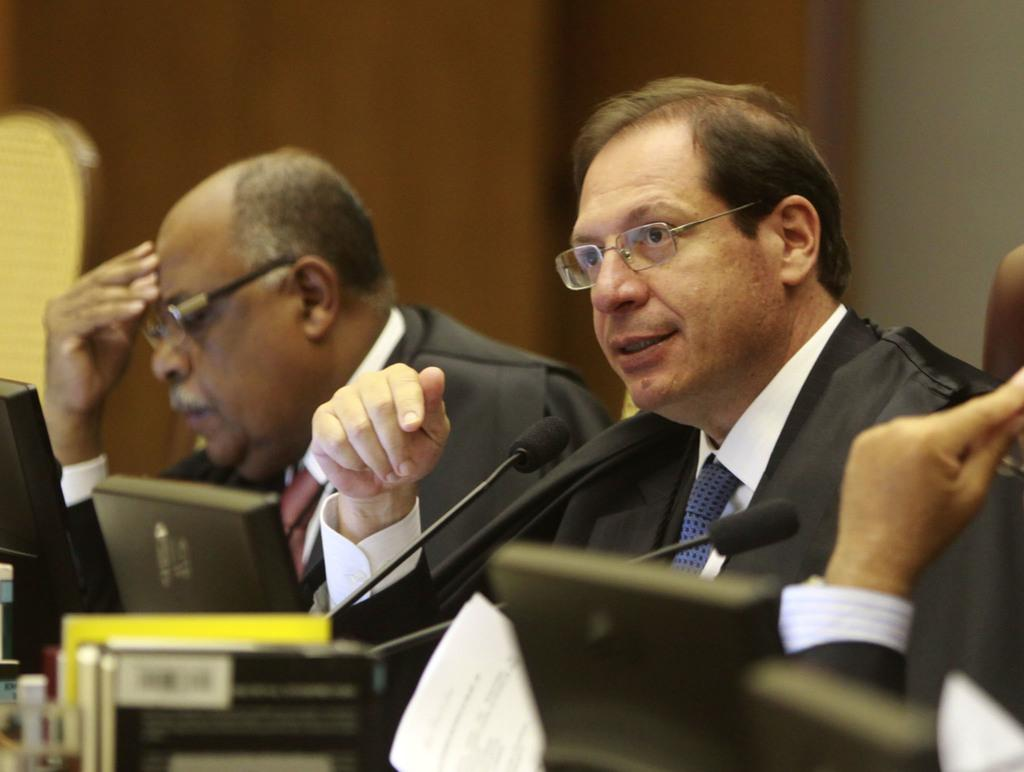Who or what can be seen in the image? There are people and mice in the image. What are the people using in the image? The people are using laptops in the image. What else can be found on the laptops? There are papers on the laptops in the image. What other objects are present in the image? There are other objects in the image, but their specific details are not mentioned in the facts. How is the background of the image depicted? The background of the image is blurred. How many girls are present in the image? The facts provided do not mention any girls in the image. What is the uncle doing in the image? The facts provided do not mention any uncles in the image. 